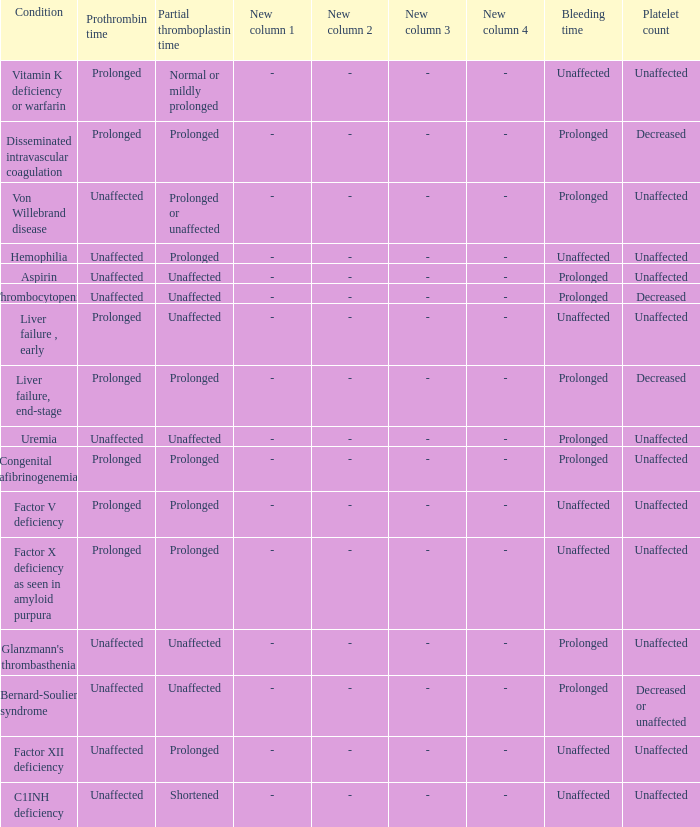Which Condition has a Bleeding time of unaffected, and a Partial thromboplastin time of prolonged, and a Prothrombin time of unaffected? Hemophilia, Factor XII deficiency. 